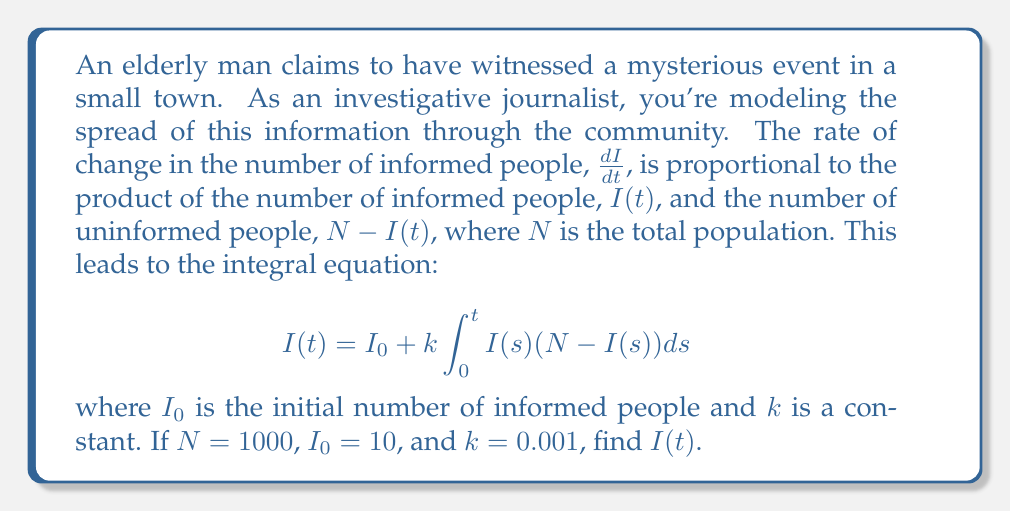Teach me how to tackle this problem. To solve this integral equation, we'll follow these steps:

1) First, we recognize this as a logistic growth model. The solution to such an equation is of the form:

   $$I(t) = \frac{N}{1 + Ce^{-kNt}}$$

   where $C$ is a constant we need to determine.

2) At $t = 0$, $I(0) = I_0 = 10$. We can use this to find $C$:

   $$10 = \frac{1000}{1 + C}$$

   $$C = \frac{1000}{10} - 1 = 99$$

3) Now we have the full solution:

   $$I(t) = \frac{1000}{1 + 99e^{-1000(0.001)t}}$$

4) Simplify:

   $$I(t) = \frac{1000}{1 + 99e^{-t}}$$

This equation represents how the number of informed people $I(t)$ changes over time $t$.
Answer: $I(t) = \frac{1000}{1 + 99e^{-t}}$ 